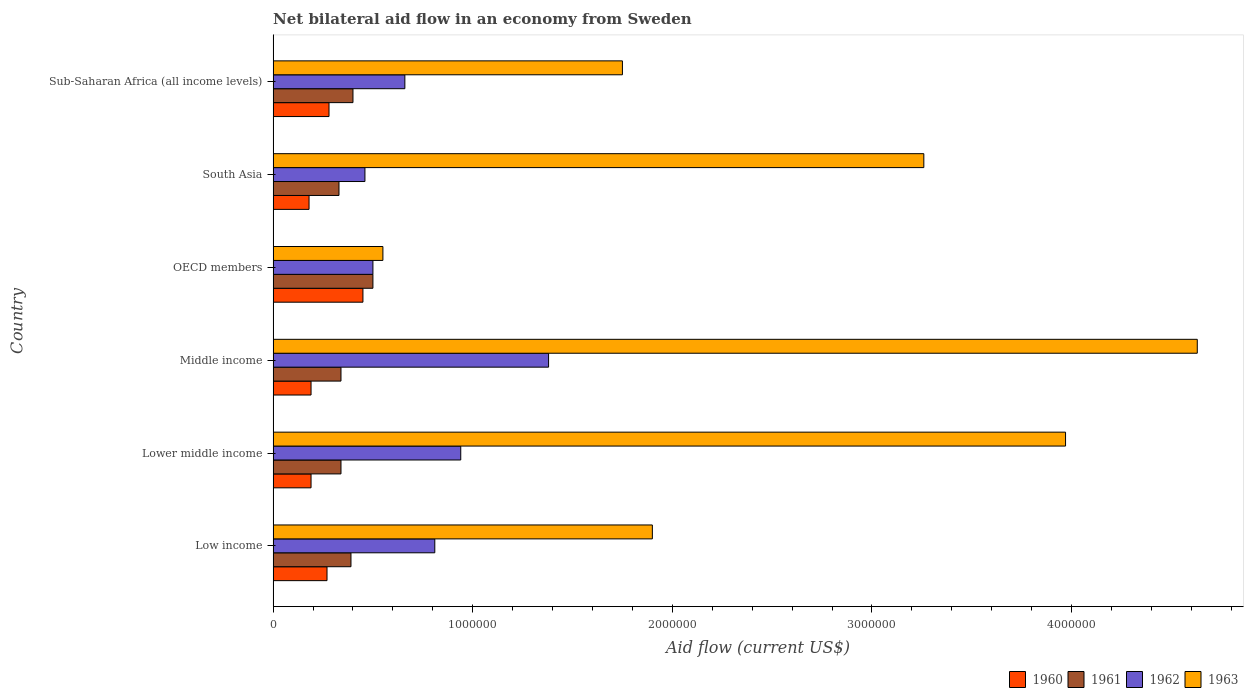How many different coloured bars are there?
Ensure brevity in your answer.  4. Are the number of bars per tick equal to the number of legend labels?
Your answer should be compact. Yes. How many bars are there on the 1st tick from the top?
Make the answer very short. 4. How many bars are there on the 5th tick from the bottom?
Your answer should be very brief. 4. In how many cases, is the number of bars for a given country not equal to the number of legend labels?
Your response must be concise. 0. What is the net bilateral aid flow in 1962 in OECD members?
Offer a terse response. 5.00e+05. Across all countries, what is the maximum net bilateral aid flow in 1962?
Give a very brief answer. 1.38e+06. In which country was the net bilateral aid flow in 1961 maximum?
Your response must be concise. OECD members. In which country was the net bilateral aid flow in 1960 minimum?
Provide a succinct answer. South Asia. What is the total net bilateral aid flow in 1961 in the graph?
Keep it short and to the point. 2.30e+06. What is the difference between the net bilateral aid flow in 1960 in Middle income and that in South Asia?
Offer a terse response. 10000. What is the difference between the net bilateral aid flow in 1962 in Sub-Saharan Africa (all income levels) and the net bilateral aid flow in 1960 in Lower middle income?
Ensure brevity in your answer.  4.70e+05. What is the average net bilateral aid flow in 1963 per country?
Provide a short and direct response. 2.68e+06. What is the difference between the net bilateral aid flow in 1961 and net bilateral aid flow in 1963 in Lower middle income?
Your answer should be very brief. -3.63e+06. In how many countries, is the net bilateral aid flow in 1963 greater than 200000 US$?
Offer a very short reply. 6. What is the ratio of the net bilateral aid flow in 1963 in Low income to that in Middle income?
Offer a very short reply. 0.41. What is the difference between the highest and the second highest net bilateral aid flow in 1960?
Your answer should be very brief. 1.70e+05. In how many countries, is the net bilateral aid flow in 1960 greater than the average net bilateral aid flow in 1960 taken over all countries?
Your response must be concise. 3. Is the sum of the net bilateral aid flow in 1962 in Low income and Lower middle income greater than the maximum net bilateral aid flow in 1961 across all countries?
Provide a short and direct response. Yes. Is it the case that in every country, the sum of the net bilateral aid flow in 1962 and net bilateral aid flow in 1960 is greater than the sum of net bilateral aid flow in 1961 and net bilateral aid flow in 1963?
Keep it short and to the point. No. What does the 1st bar from the top in Low income represents?
Ensure brevity in your answer.  1963. What does the 3rd bar from the bottom in Sub-Saharan Africa (all income levels) represents?
Offer a terse response. 1962. How many bars are there?
Your response must be concise. 24. How many countries are there in the graph?
Your answer should be very brief. 6. Are the values on the major ticks of X-axis written in scientific E-notation?
Ensure brevity in your answer.  No. How many legend labels are there?
Make the answer very short. 4. What is the title of the graph?
Offer a terse response. Net bilateral aid flow in an economy from Sweden. Does "1989" appear as one of the legend labels in the graph?
Your response must be concise. No. What is the label or title of the X-axis?
Your answer should be very brief. Aid flow (current US$). What is the Aid flow (current US$) in 1960 in Low income?
Give a very brief answer. 2.70e+05. What is the Aid flow (current US$) of 1961 in Low income?
Ensure brevity in your answer.  3.90e+05. What is the Aid flow (current US$) in 1962 in Low income?
Offer a very short reply. 8.10e+05. What is the Aid flow (current US$) in 1963 in Low income?
Your response must be concise. 1.90e+06. What is the Aid flow (current US$) in 1960 in Lower middle income?
Provide a succinct answer. 1.90e+05. What is the Aid flow (current US$) in 1961 in Lower middle income?
Ensure brevity in your answer.  3.40e+05. What is the Aid flow (current US$) of 1962 in Lower middle income?
Offer a very short reply. 9.40e+05. What is the Aid flow (current US$) of 1963 in Lower middle income?
Your answer should be very brief. 3.97e+06. What is the Aid flow (current US$) in 1962 in Middle income?
Your answer should be compact. 1.38e+06. What is the Aid flow (current US$) of 1963 in Middle income?
Offer a terse response. 4.63e+06. What is the Aid flow (current US$) of 1963 in OECD members?
Your answer should be compact. 5.50e+05. What is the Aid flow (current US$) of 1961 in South Asia?
Give a very brief answer. 3.30e+05. What is the Aid flow (current US$) in 1962 in South Asia?
Keep it short and to the point. 4.60e+05. What is the Aid flow (current US$) of 1963 in South Asia?
Offer a terse response. 3.26e+06. What is the Aid flow (current US$) in 1962 in Sub-Saharan Africa (all income levels)?
Provide a short and direct response. 6.60e+05. What is the Aid flow (current US$) of 1963 in Sub-Saharan Africa (all income levels)?
Provide a succinct answer. 1.75e+06. Across all countries, what is the maximum Aid flow (current US$) of 1961?
Offer a very short reply. 5.00e+05. Across all countries, what is the maximum Aid flow (current US$) of 1962?
Keep it short and to the point. 1.38e+06. Across all countries, what is the maximum Aid flow (current US$) in 1963?
Keep it short and to the point. 4.63e+06. Across all countries, what is the minimum Aid flow (current US$) in 1961?
Offer a terse response. 3.30e+05. Across all countries, what is the minimum Aid flow (current US$) in 1963?
Your answer should be very brief. 5.50e+05. What is the total Aid flow (current US$) in 1960 in the graph?
Provide a succinct answer. 1.56e+06. What is the total Aid flow (current US$) of 1961 in the graph?
Give a very brief answer. 2.30e+06. What is the total Aid flow (current US$) in 1962 in the graph?
Provide a short and direct response. 4.75e+06. What is the total Aid flow (current US$) in 1963 in the graph?
Offer a very short reply. 1.61e+07. What is the difference between the Aid flow (current US$) in 1960 in Low income and that in Lower middle income?
Your answer should be very brief. 8.00e+04. What is the difference between the Aid flow (current US$) in 1963 in Low income and that in Lower middle income?
Give a very brief answer. -2.07e+06. What is the difference between the Aid flow (current US$) of 1960 in Low income and that in Middle income?
Your answer should be very brief. 8.00e+04. What is the difference between the Aid flow (current US$) of 1961 in Low income and that in Middle income?
Make the answer very short. 5.00e+04. What is the difference between the Aid flow (current US$) of 1962 in Low income and that in Middle income?
Provide a succinct answer. -5.70e+05. What is the difference between the Aid flow (current US$) in 1963 in Low income and that in Middle income?
Your response must be concise. -2.73e+06. What is the difference between the Aid flow (current US$) in 1962 in Low income and that in OECD members?
Your answer should be very brief. 3.10e+05. What is the difference between the Aid flow (current US$) of 1963 in Low income and that in OECD members?
Provide a short and direct response. 1.35e+06. What is the difference between the Aid flow (current US$) of 1960 in Low income and that in South Asia?
Offer a very short reply. 9.00e+04. What is the difference between the Aid flow (current US$) in 1963 in Low income and that in South Asia?
Your response must be concise. -1.36e+06. What is the difference between the Aid flow (current US$) in 1960 in Low income and that in Sub-Saharan Africa (all income levels)?
Provide a succinct answer. -10000. What is the difference between the Aid flow (current US$) of 1962 in Low income and that in Sub-Saharan Africa (all income levels)?
Provide a short and direct response. 1.50e+05. What is the difference between the Aid flow (current US$) in 1963 in Low income and that in Sub-Saharan Africa (all income levels)?
Provide a short and direct response. 1.50e+05. What is the difference between the Aid flow (current US$) of 1960 in Lower middle income and that in Middle income?
Keep it short and to the point. 0. What is the difference between the Aid flow (current US$) of 1961 in Lower middle income and that in Middle income?
Provide a succinct answer. 0. What is the difference between the Aid flow (current US$) in 1962 in Lower middle income and that in Middle income?
Your answer should be very brief. -4.40e+05. What is the difference between the Aid flow (current US$) of 1963 in Lower middle income and that in Middle income?
Give a very brief answer. -6.60e+05. What is the difference between the Aid flow (current US$) in 1960 in Lower middle income and that in OECD members?
Provide a short and direct response. -2.60e+05. What is the difference between the Aid flow (current US$) in 1962 in Lower middle income and that in OECD members?
Give a very brief answer. 4.40e+05. What is the difference between the Aid flow (current US$) of 1963 in Lower middle income and that in OECD members?
Ensure brevity in your answer.  3.42e+06. What is the difference between the Aid flow (current US$) of 1960 in Lower middle income and that in South Asia?
Give a very brief answer. 10000. What is the difference between the Aid flow (current US$) of 1961 in Lower middle income and that in South Asia?
Your answer should be compact. 10000. What is the difference between the Aid flow (current US$) of 1962 in Lower middle income and that in South Asia?
Offer a terse response. 4.80e+05. What is the difference between the Aid flow (current US$) in 1963 in Lower middle income and that in South Asia?
Keep it short and to the point. 7.10e+05. What is the difference between the Aid flow (current US$) in 1963 in Lower middle income and that in Sub-Saharan Africa (all income levels)?
Keep it short and to the point. 2.22e+06. What is the difference between the Aid flow (current US$) of 1961 in Middle income and that in OECD members?
Ensure brevity in your answer.  -1.60e+05. What is the difference between the Aid flow (current US$) in 1962 in Middle income and that in OECD members?
Offer a very short reply. 8.80e+05. What is the difference between the Aid flow (current US$) of 1963 in Middle income and that in OECD members?
Make the answer very short. 4.08e+06. What is the difference between the Aid flow (current US$) in 1962 in Middle income and that in South Asia?
Keep it short and to the point. 9.20e+05. What is the difference between the Aid flow (current US$) in 1963 in Middle income and that in South Asia?
Give a very brief answer. 1.37e+06. What is the difference between the Aid flow (current US$) of 1961 in Middle income and that in Sub-Saharan Africa (all income levels)?
Provide a short and direct response. -6.00e+04. What is the difference between the Aid flow (current US$) of 1962 in Middle income and that in Sub-Saharan Africa (all income levels)?
Ensure brevity in your answer.  7.20e+05. What is the difference between the Aid flow (current US$) in 1963 in Middle income and that in Sub-Saharan Africa (all income levels)?
Offer a terse response. 2.88e+06. What is the difference between the Aid flow (current US$) in 1963 in OECD members and that in South Asia?
Give a very brief answer. -2.71e+06. What is the difference between the Aid flow (current US$) in 1963 in OECD members and that in Sub-Saharan Africa (all income levels)?
Your answer should be compact. -1.20e+06. What is the difference between the Aid flow (current US$) of 1960 in South Asia and that in Sub-Saharan Africa (all income levels)?
Provide a succinct answer. -1.00e+05. What is the difference between the Aid flow (current US$) in 1961 in South Asia and that in Sub-Saharan Africa (all income levels)?
Your response must be concise. -7.00e+04. What is the difference between the Aid flow (current US$) in 1962 in South Asia and that in Sub-Saharan Africa (all income levels)?
Ensure brevity in your answer.  -2.00e+05. What is the difference between the Aid flow (current US$) of 1963 in South Asia and that in Sub-Saharan Africa (all income levels)?
Your answer should be very brief. 1.51e+06. What is the difference between the Aid flow (current US$) of 1960 in Low income and the Aid flow (current US$) of 1961 in Lower middle income?
Provide a succinct answer. -7.00e+04. What is the difference between the Aid flow (current US$) in 1960 in Low income and the Aid flow (current US$) in 1962 in Lower middle income?
Provide a succinct answer. -6.70e+05. What is the difference between the Aid flow (current US$) of 1960 in Low income and the Aid flow (current US$) of 1963 in Lower middle income?
Keep it short and to the point. -3.70e+06. What is the difference between the Aid flow (current US$) in 1961 in Low income and the Aid flow (current US$) in 1962 in Lower middle income?
Provide a succinct answer. -5.50e+05. What is the difference between the Aid flow (current US$) in 1961 in Low income and the Aid flow (current US$) in 1963 in Lower middle income?
Keep it short and to the point. -3.58e+06. What is the difference between the Aid flow (current US$) in 1962 in Low income and the Aid flow (current US$) in 1963 in Lower middle income?
Give a very brief answer. -3.16e+06. What is the difference between the Aid flow (current US$) in 1960 in Low income and the Aid flow (current US$) in 1962 in Middle income?
Your response must be concise. -1.11e+06. What is the difference between the Aid flow (current US$) in 1960 in Low income and the Aid flow (current US$) in 1963 in Middle income?
Ensure brevity in your answer.  -4.36e+06. What is the difference between the Aid flow (current US$) of 1961 in Low income and the Aid flow (current US$) of 1962 in Middle income?
Offer a very short reply. -9.90e+05. What is the difference between the Aid flow (current US$) in 1961 in Low income and the Aid flow (current US$) in 1963 in Middle income?
Keep it short and to the point. -4.24e+06. What is the difference between the Aid flow (current US$) of 1962 in Low income and the Aid flow (current US$) of 1963 in Middle income?
Offer a very short reply. -3.82e+06. What is the difference between the Aid flow (current US$) in 1960 in Low income and the Aid flow (current US$) in 1961 in OECD members?
Your answer should be very brief. -2.30e+05. What is the difference between the Aid flow (current US$) of 1960 in Low income and the Aid flow (current US$) of 1963 in OECD members?
Make the answer very short. -2.80e+05. What is the difference between the Aid flow (current US$) of 1961 in Low income and the Aid flow (current US$) of 1962 in OECD members?
Ensure brevity in your answer.  -1.10e+05. What is the difference between the Aid flow (current US$) of 1961 in Low income and the Aid flow (current US$) of 1963 in OECD members?
Your answer should be compact. -1.60e+05. What is the difference between the Aid flow (current US$) of 1960 in Low income and the Aid flow (current US$) of 1961 in South Asia?
Give a very brief answer. -6.00e+04. What is the difference between the Aid flow (current US$) in 1960 in Low income and the Aid flow (current US$) in 1962 in South Asia?
Your response must be concise. -1.90e+05. What is the difference between the Aid flow (current US$) of 1960 in Low income and the Aid flow (current US$) of 1963 in South Asia?
Provide a succinct answer. -2.99e+06. What is the difference between the Aid flow (current US$) of 1961 in Low income and the Aid flow (current US$) of 1962 in South Asia?
Make the answer very short. -7.00e+04. What is the difference between the Aid flow (current US$) of 1961 in Low income and the Aid flow (current US$) of 1963 in South Asia?
Provide a succinct answer. -2.87e+06. What is the difference between the Aid flow (current US$) of 1962 in Low income and the Aid flow (current US$) of 1963 in South Asia?
Ensure brevity in your answer.  -2.45e+06. What is the difference between the Aid flow (current US$) in 1960 in Low income and the Aid flow (current US$) in 1961 in Sub-Saharan Africa (all income levels)?
Offer a very short reply. -1.30e+05. What is the difference between the Aid flow (current US$) in 1960 in Low income and the Aid flow (current US$) in 1962 in Sub-Saharan Africa (all income levels)?
Your answer should be very brief. -3.90e+05. What is the difference between the Aid flow (current US$) in 1960 in Low income and the Aid flow (current US$) in 1963 in Sub-Saharan Africa (all income levels)?
Provide a short and direct response. -1.48e+06. What is the difference between the Aid flow (current US$) in 1961 in Low income and the Aid flow (current US$) in 1962 in Sub-Saharan Africa (all income levels)?
Provide a short and direct response. -2.70e+05. What is the difference between the Aid flow (current US$) of 1961 in Low income and the Aid flow (current US$) of 1963 in Sub-Saharan Africa (all income levels)?
Offer a terse response. -1.36e+06. What is the difference between the Aid flow (current US$) of 1962 in Low income and the Aid flow (current US$) of 1963 in Sub-Saharan Africa (all income levels)?
Offer a very short reply. -9.40e+05. What is the difference between the Aid flow (current US$) of 1960 in Lower middle income and the Aid flow (current US$) of 1961 in Middle income?
Offer a very short reply. -1.50e+05. What is the difference between the Aid flow (current US$) in 1960 in Lower middle income and the Aid flow (current US$) in 1962 in Middle income?
Make the answer very short. -1.19e+06. What is the difference between the Aid flow (current US$) in 1960 in Lower middle income and the Aid flow (current US$) in 1963 in Middle income?
Give a very brief answer. -4.44e+06. What is the difference between the Aid flow (current US$) in 1961 in Lower middle income and the Aid flow (current US$) in 1962 in Middle income?
Offer a terse response. -1.04e+06. What is the difference between the Aid flow (current US$) in 1961 in Lower middle income and the Aid flow (current US$) in 1963 in Middle income?
Give a very brief answer. -4.29e+06. What is the difference between the Aid flow (current US$) in 1962 in Lower middle income and the Aid flow (current US$) in 1963 in Middle income?
Ensure brevity in your answer.  -3.69e+06. What is the difference between the Aid flow (current US$) of 1960 in Lower middle income and the Aid flow (current US$) of 1961 in OECD members?
Give a very brief answer. -3.10e+05. What is the difference between the Aid flow (current US$) of 1960 in Lower middle income and the Aid flow (current US$) of 1962 in OECD members?
Keep it short and to the point. -3.10e+05. What is the difference between the Aid flow (current US$) of 1960 in Lower middle income and the Aid flow (current US$) of 1963 in OECD members?
Offer a very short reply. -3.60e+05. What is the difference between the Aid flow (current US$) of 1961 in Lower middle income and the Aid flow (current US$) of 1962 in OECD members?
Offer a very short reply. -1.60e+05. What is the difference between the Aid flow (current US$) of 1961 in Lower middle income and the Aid flow (current US$) of 1963 in OECD members?
Make the answer very short. -2.10e+05. What is the difference between the Aid flow (current US$) of 1960 in Lower middle income and the Aid flow (current US$) of 1963 in South Asia?
Your response must be concise. -3.07e+06. What is the difference between the Aid flow (current US$) in 1961 in Lower middle income and the Aid flow (current US$) in 1962 in South Asia?
Offer a terse response. -1.20e+05. What is the difference between the Aid flow (current US$) in 1961 in Lower middle income and the Aid flow (current US$) in 1963 in South Asia?
Your answer should be very brief. -2.92e+06. What is the difference between the Aid flow (current US$) in 1962 in Lower middle income and the Aid flow (current US$) in 1963 in South Asia?
Offer a terse response. -2.32e+06. What is the difference between the Aid flow (current US$) in 1960 in Lower middle income and the Aid flow (current US$) in 1962 in Sub-Saharan Africa (all income levels)?
Your answer should be compact. -4.70e+05. What is the difference between the Aid flow (current US$) in 1960 in Lower middle income and the Aid flow (current US$) in 1963 in Sub-Saharan Africa (all income levels)?
Provide a short and direct response. -1.56e+06. What is the difference between the Aid flow (current US$) in 1961 in Lower middle income and the Aid flow (current US$) in 1962 in Sub-Saharan Africa (all income levels)?
Make the answer very short. -3.20e+05. What is the difference between the Aid flow (current US$) in 1961 in Lower middle income and the Aid flow (current US$) in 1963 in Sub-Saharan Africa (all income levels)?
Your response must be concise. -1.41e+06. What is the difference between the Aid flow (current US$) in 1962 in Lower middle income and the Aid flow (current US$) in 1963 in Sub-Saharan Africa (all income levels)?
Your answer should be very brief. -8.10e+05. What is the difference between the Aid flow (current US$) in 1960 in Middle income and the Aid flow (current US$) in 1961 in OECD members?
Make the answer very short. -3.10e+05. What is the difference between the Aid flow (current US$) of 1960 in Middle income and the Aid flow (current US$) of 1962 in OECD members?
Ensure brevity in your answer.  -3.10e+05. What is the difference between the Aid flow (current US$) of 1960 in Middle income and the Aid flow (current US$) of 1963 in OECD members?
Provide a succinct answer. -3.60e+05. What is the difference between the Aid flow (current US$) in 1961 in Middle income and the Aid flow (current US$) in 1962 in OECD members?
Make the answer very short. -1.60e+05. What is the difference between the Aid flow (current US$) in 1962 in Middle income and the Aid flow (current US$) in 1963 in OECD members?
Offer a terse response. 8.30e+05. What is the difference between the Aid flow (current US$) in 1960 in Middle income and the Aid flow (current US$) in 1961 in South Asia?
Ensure brevity in your answer.  -1.40e+05. What is the difference between the Aid flow (current US$) in 1960 in Middle income and the Aid flow (current US$) in 1962 in South Asia?
Give a very brief answer. -2.70e+05. What is the difference between the Aid flow (current US$) in 1960 in Middle income and the Aid flow (current US$) in 1963 in South Asia?
Offer a very short reply. -3.07e+06. What is the difference between the Aid flow (current US$) in 1961 in Middle income and the Aid flow (current US$) in 1962 in South Asia?
Provide a short and direct response. -1.20e+05. What is the difference between the Aid flow (current US$) of 1961 in Middle income and the Aid flow (current US$) of 1963 in South Asia?
Make the answer very short. -2.92e+06. What is the difference between the Aid flow (current US$) of 1962 in Middle income and the Aid flow (current US$) of 1963 in South Asia?
Your answer should be very brief. -1.88e+06. What is the difference between the Aid flow (current US$) of 1960 in Middle income and the Aid flow (current US$) of 1961 in Sub-Saharan Africa (all income levels)?
Your answer should be compact. -2.10e+05. What is the difference between the Aid flow (current US$) in 1960 in Middle income and the Aid flow (current US$) in 1962 in Sub-Saharan Africa (all income levels)?
Give a very brief answer. -4.70e+05. What is the difference between the Aid flow (current US$) of 1960 in Middle income and the Aid flow (current US$) of 1963 in Sub-Saharan Africa (all income levels)?
Keep it short and to the point. -1.56e+06. What is the difference between the Aid flow (current US$) of 1961 in Middle income and the Aid flow (current US$) of 1962 in Sub-Saharan Africa (all income levels)?
Keep it short and to the point. -3.20e+05. What is the difference between the Aid flow (current US$) in 1961 in Middle income and the Aid flow (current US$) in 1963 in Sub-Saharan Africa (all income levels)?
Provide a short and direct response. -1.41e+06. What is the difference between the Aid flow (current US$) of 1962 in Middle income and the Aid flow (current US$) of 1963 in Sub-Saharan Africa (all income levels)?
Ensure brevity in your answer.  -3.70e+05. What is the difference between the Aid flow (current US$) in 1960 in OECD members and the Aid flow (current US$) in 1961 in South Asia?
Your answer should be very brief. 1.20e+05. What is the difference between the Aid flow (current US$) of 1960 in OECD members and the Aid flow (current US$) of 1963 in South Asia?
Your answer should be compact. -2.81e+06. What is the difference between the Aid flow (current US$) of 1961 in OECD members and the Aid flow (current US$) of 1962 in South Asia?
Offer a terse response. 4.00e+04. What is the difference between the Aid flow (current US$) of 1961 in OECD members and the Aid flow (current US$) of 1963 in South Asia?
Your response must be concise. -2.76e+06. What is the difference between the Aid flow (current US$) of 1962 in OECD members and the Aid flow (current US$) of 1963 in South Asia?
Your answer should be compact. -2.76e+06. What is the difference between the Aid flow (current US$) of 1960 in OECD members and the Aid flow (current US$) of 1961 in Sub-Saharan Africa (all income levels)?
Offer a very short reply. 5.00e+04. What is the difference between the Aid flow (current US$) of 1960 in OECD members and the Aid flow (current US$) of 1963 in Sub-Saharan Africa (all income levels)?
Make the answer very short. -1.30e+06. What is the difference between the Aid flow (current US$) of 1961 in OECD members and the Aid flow (current US$) of 1963 in Sub-Saharan Africa (all income levels)?
Your response must be concise. -1.25e+06. What is the difference between the Aid flow (current US$) of 1962 in OECD members and the Aid flow (current US$) of 1963 in Sub-Saharan Africa (all income levels)?
Ensure brevity in your answer.  -1.25e+06. What is the difference between the Aid flow (current US$) in 1960 in South Asia and the Aid flow (current US$) in 1961 in Sub-Saharan Africa (all income levels)?
Your answer should be compact. -2.20e+05. What is the difference between the Aid flow (current US$) in 1960 in South Asia and the Aid flow (current US$) in 1962 in Sub-Saharan Africa (all income levels)?
Provide a short and direct response. -4.80e+05. What is the difference between the Aid flow (current US$) in 1960 in South Asia and the Aid flow (current US$) in 1963 in Sub-Saharan Africa (all income levels)?
Make the answer very short. -1.57e+06. What is the difference between the Aid flow (current US$) in 1961 in South Asia and the Aid flow (current US$) in 1962 in Sub-Saharan Africa (all income levels)?
Offer a very short reply. -3.30e+05. What is the difference between the Aid flow (current US$) in 1961 in South Asia and the Aid flow (current US$) in 1963 in Sub-Saharan Africa (all income levels)?
Ensure brevity in your answer.  -1.42e+06. What is the difference between the Aid flow (current US$) in 1962 in South Asia and the Aid flow (current US$) in 1963 in Sub-Saharan Africa (all income levels)?
Provide a short and direct response. -1.29e+06. What is the average Aid flow (current US$) of 1961 per country?
Give a very brief answer. 3.83e+05. What is the average Aid flow (current US$) of 1962 per country?
Your answer should be compact. 7.92e+05. What is the average Aid flow (current US$) of 1963 per country?
Make the answer very short. 2.68e+06. What is the difference between the Aid flow (current US$) of 1960 and Aid flow (current US$) of 1961 in Low income?
Offer a very short reply. -1.20e+05. What is the difference between the Aid flow (current US$) in 1960 and Aid flow (current US$) in 1962 in Low income?
Provide a succinct answer. -5.40e+05. What is the difference between the Aid flow (current US$) in 1960 and Aid flow (current US$) in 1963 in Low income?
Keep it short and to the point. -1.63e+06. What is the difference between the Aid flow (current US$) of 1961 and Aid flow (current US$) of 1962 in Low income?
Offer a very short reply. -4.20e+05. What is the difference between the Aid flow (current US$) of 1961 and Aid flow (current US$) of 1963 in Low income?
Provide a short and direct response. -1.51e+06. What is the difference between the Aid flow (current US$) in 1962 and Aid flow (current US$) in 1963 in Low income?
Your response must be concise. -1.09e+06. What is the difference between the Aid flow (current US$) of 1960 and Aid flow (current US$) of 1961 in Lower middle income?
Offer a terse response. -1.50e+05. What is the difference between the Aid flow (current US$) in 1960 and Aid flow (current US$) in 1962 in Lower middle income?
Make the answer very short. -7.50e+05. What is the difference between the Aid flow (current US$) in 1960 and Aid flow (current US$) in 1963 in Lower middle income?
Make the answer very short. -3.78e+06. What is the difference between the Aid flow (current US$) in 1961 and Aid flow (current US$) in 1962 in Lower middle income?
Make the answer very short. -6.00e+05. What is the difference between the Aid flow (current US$) in 1961 and Aid flow (current US$) in 1963 in Lower middle income?
Your answer should be very brief. -3.63e+06. What is the difference between the Aid flow (current US$) in 1962 and Aid flow (current US$) in 1963 in Lower middle income?
Make the answer very short. -3.03e+06. What is the difference between the Aid flow (current US$) in 1960 and Aid flow (current US$) in 1962 in Middle income?
Your answer should be very brief. -1.19e+06. What is the difference between the Aid flow (current US$) of 1960 and Aid flow (current US$) of 1963 in Middle income?
Provide a short and direct response. -4.44e+06. What is the difference between the Aid flow (current US$) of 1961 and Aid flow (current US$) of 1962 in Middle income?
Ensure brevity in your answer.  -1.04e+06. What is the difference between the Aid flow (current US$) of 1961 and Aid flow (current US$) of 1963 in Middle income?
Make the answer very short. -4.29e+06. What is the difference between the Aid flow (current US$) of 1962 and Aid flow (current US$) of 1963 in Middle income?
Give a very brief answer. -3.25e+06. What is the difference between the Aid flow (current US$) of 1961 and Aid flow (current US$) of 1963 in OECD members?
Offer a terse response. -5.00e+04. What is the difference between the Aid flow (current US$) in 1962 and Aid flow (current US$) in 1963 in OECD members?
Offer a terse response. -5.00e+04. What is the difference between the Aid flow (current US$) of 1960 and Aid flow (current US$) of 1962 in South Asia?
Make the answer very short. -2.80e+05. What is the difference between the Aid flow (current US$) in 1960 and Aid flow (current US$) in 1963 in South Asia?
Offer a terse response. -3.08e+06. What is the difference between the Aid flow (current US$) of 1961 and Aid flow (current US$) of 1962 in South Asia?
Make the answer very short. -1.30e+05. What is the difference between the Aid flow (current US$) in 1961 and Aid flow (current US$) in 1963 in South Asia?
Offer a terse response. -2.93e+06. What is the difference between the Aid flow (current US$) of 1962 and Aid flow (current US$) of 1963 in South Asia?
Ensure brevity in your answer.  -2.80e+06. What is the difference between the Aid flow (current US$) in 1960 and Aid flow (current US$) in 1961 in Sub-Saharan Africa (all income levels)?
Ensure brevity in your answer.  -1.20e+05. What is the difference between the Aid flow (current US$) in 1960 and Aid flow (current US$) in 1962 in Sub-Saharan Africa (all income levels)?
Offer a terse response. -3.80e+05. What is the difference between the Aid flow (current US$) in 1960 and Aid flow (current US$) in 1963 in Sub-Saharan Africa (all income levels)?
Your answer should be very brief. -1.47e+06. What is the difference between the Aid flow (current US$) in 1961 and Aid flow (current US$) in 1963 in Sub-Saharan Africa (all income levels)?
Give a very brief answer. -1.35e+06. What is the difference between the Aid flow (current US$) in 1962 and Aid flow (current US$) in 1963 in Sub-Saharan Africa (all income levels)?
Your response must be concise. -1.09e+06. What is the ratio of the Aid flow (current US$) in 1960 in Low income to that in Lower middle income?
Offer a very short reply. 1.42. What is the ratio of the Aid flow (current US$) of 1961 in Low income to that in Lower middle income?
Provide a succinct answer. 1.15. What is the ratio of the Aid flow (current US$) in 1962 in Low income to that in Lower middle income?
Offer a very short reply. 0.86. What is the ratio of the Aid flow (current US$) of 1963 in Low income to that in Lower middle income?
Ensure brevity in your answer.  0.48. What is the ratio of the Aid flow (current US$) of 1960 in Low income to that in Middle income?
Give a very brief answer. 1.42. What is the ratio of the Aid flow (current US$) of 1961 in Low income to that in Middle income?
Your answer should be very brief. 1.15. What is the ratio of the Aid flow (current US$) in 1962 in Low income to that in Middle income?
Provide a short and direct response. 0.59. What is the ratio of the Aid flow (current US$) of 1963 in Low income to that in Middle income?
Provide a short and direct response. 0.41. What is the ratio of the Aid flow (current US$) in 1960 in Low income to that in OECD members?
Your answer should be very brief. 0.6. What is the ratio of the Aid flow (current US$) in 1961 in Low income to that in OECD members?
Your answer should be compact. 0.78. What is the ratio of the Aid flow (current US$) of 1962 in Low income to that in OECD members?
Your answer should be compact. 1.62. What is the ratio of the Aid flow (current US$) in 1963 in Low income to that in OECD members?
Give a very brief answer. 3.45. What is the ratio of the Aid flow (current US$) in 1960 in Low income to that in South Asia?
Offer a terse response. 1.5. What is the ratio of the Aid flow (current US$) in 1961 in Low income to that in South Asia?
Offer a very short reply. 1.18. What is the ratio of the Aid flow (current US$) in 1962 in Low income to that in South Asia?
Keep it short and to the point. 1.76. What is the ratio of the Aid flow (current US$) in 1963 in Low income to that in South Asia?
Offer a very short reply. 0.58. What is the ratio of the Aid flow (current US$) of 1961 in Low income to that in Sub-Saharan Africa (all income levels)?
Ensure brevity in your answer.  0.97. What is the ratio of the Aid flow (current US$) of 1962 in Low income to that in Sub-Saharan Africa (all income levels)?
Keep it short and to the point. 1.23. What is the ratio of the Aid flow (current US$) in 1963 in Low income to that in Sub-Saharan Africa (all income levels)?
Offer a terse response. 1.09. What is the ratio of the Aid flow (current US$) of 1961 in Lower middle income to that in Middle income?
Keep it short and to the point. 1. What is the ratio of the Aid flow (current US$) of 1962 in Lower middle income to that in Middle income?
Your answer should be compact. 0.68. What is the ratio of the Aid flow (current US$) of 1963 in Lower middle income to that in Middle income?
Your response must be concise. 0.86. What is the ratio of the Aid flow (current US$) of 1960 in Lower middle income to that in OECD members?
Make the answer very short. 0.42. What is the ratio of the Aid flow (current US$) of 1961 in Lower middle income to that in OECD members?
Make the answer very short. 0.68. What is the ratio of the Aid flow (current US$) in 1962 in Lower middle income to that in OECD members?
Make the answer very short. 1.88. What is the ratio of the Aid flow (current US$) of 1963 in Lower middle income to that in OECD members?
Your answer should be very brief. 7.22. What is the ratio of the Aid flow (current US$) of 1960 in Lower middle income to that in South Asia?
Provide a succinct answer. 1.06. What is the ratio of the Aid flow (current US$) of 1961 in Lower middle income to that in South Asia?
Give a very brief answer. 1.03. What is the ratio of the Aid flow (current US$) in 1962 in Lower middle income to that in South Asia?
Your answer should be compact. 2.04. What is the ratio of the Aid flow (current US$) of 1963 in Lower middle income to that in South Asia?
Your answer should be very brief. 1.22. What is the ratio of the Aid flow (current US$) of 1960 in Lower middle income to that in Sub-Saharan Africa (all income levels)?
Offer a terse response. 0.68. What is the ratio of the Aid flow (current US$) of 1961 in Lower middle income to that in Sub-Saharan Africa (all income levels)?
Offer a terse response. 0.85. What is the ratio of the Aid flow (current US$) in 1962 in Lower middle income to that in Sub-Saharan Africa (all income levels)?
Keep it short and to the point. 1.42. What is the ratio of the Aid flow (current US$) of 1963 in Lower middle income to that in Sub-Saharan Africa (all income levels)?
Make the answer very short. 2.27. What is the ratio of the Aid flow (current US$) of 1960 in Middle income to that in OECD members?
Offer a very short reply. 0.42. What is the ratio of the Aid flow (current US$) in 1961 in Middle income to that in OECD members?
Your response must be concise. 0.68. What is the ratio of the Aid flow (current US$) of 1962 in Middle income to that in OECD members?
Your answer should be compact. 2.76. What is the ratio of the Aid flow (current US$) of 1963 in Middle income to that in OECD members?
Your answer should be very brief. 8.42. What is the ratio of the Aid flow (current US$) of 1960 in Middle income to that in South Asia?
Your answer should be compact. 1.06. What is the ratio of the Aid flow (current US$) of 1961 in Middle income to that in South Asia?
Give a very brief answer. 1.03. What is the ratio of the Aid flow (current US$) in 1963 in Middle income to that in South Asia?
Offer a terse response. 1.42. What is the ratio of the Aid flow (current US$) in 1960 in Middle income to that in Sub-Saharan Africa (all income levels)?
Provide a short and direct response. 0.68. What is the ratio of the Aid flow (current US$) in 1961 in Middle income to that in Sub-Saharan Africa (all income levels)?
Provide a succinct answer. 0.85. What is the ratio of the Aid flow (current US$) in 1962 in Middle income to that in Sub-Saharan Africa (all income levels)?
Your answer should be compact. 2.09. What is the ratio of the Aid flow (current US$) in 1963 in Middle income to that in Sub-Saharan Africa (all income levels)?
Keep it short and to the point. 2.65. What is the ratio of the Aid flow (current US$) of 1960 in OECD members to that in South Asia?
Give a very brief answer. 2.5. What is the ratio of the Aid flow (current US$) of 1961 in OECD members to that in South Asia?
Ensure brevity in your answer.  1.52. What is the ratio of the Aid flow (current US$) of 1962 in OECD members to that in South Asia?
Give a very brief answer. 1.09. What is the ratio of the Aid flow (current US$) in 1963 in OECD members to that in South Asia?
Provide a short and direct response. 0.17. What is the ratio of the Aid flow (current US$) of 1960 in OECD members to that in Sub-Saharan Africa (all income levels)?
Offer a very short reply. 1.61. What is the ratio of the Aid flow (current US$) in 1962 in OECD members to that in Sub-Saharan Africa (all income levels)?
Provide a succinct answer. 0.76. What is the ratio of the Aid flow (current US$) of 1963 in OECD members to that in Sub-Saharan Africa (all income levels)?
Give a very brief answer. 0.31. What is the ratio of the Aid flow (current US$) of 1960 in South Asia to that in Sub-Saharan Africa (all income levels)?
Offer a terse response. 0.64. What is the ratio of the Aid flow (current US$) of 1961 in South Asia to that in Sub-Saharan Africa (all income levels)?
Offer a terse response. 0.82. What is the ratio of the Aid flow (current US$) of 1962 in South Asia to that in Sub-Saharan Africa (all income levels)?
Your response must be concise. 0.7. What is the ratio of the Aid flow (current US$) of 1963 in South Asia to that in Sub-Saharan Africa (all income levels)?
Your response must be concise. 1.86. What is the difference between the highest and the second highest Aid flow (current US$) of 1961?
Make the answer very short. 1.00e+05. What is the difference between the highest and the second highest Aid flow (current US$) of 1963?
Your answer should be compact. 6.60e+05. What is the difference between the highest and the lowest Aid flow (current US$) in 1961?
Your answer should be compact. 1.70e+05. What is the difference between the highest and the lowest Aid flow (current US$) of 1962?
Provide a succinct answer. 9.20e+05. What is the difference between the highest and the lowest Aid flow (current US$) of 1963?
Provide a short and direct response. 4.08e+06. 